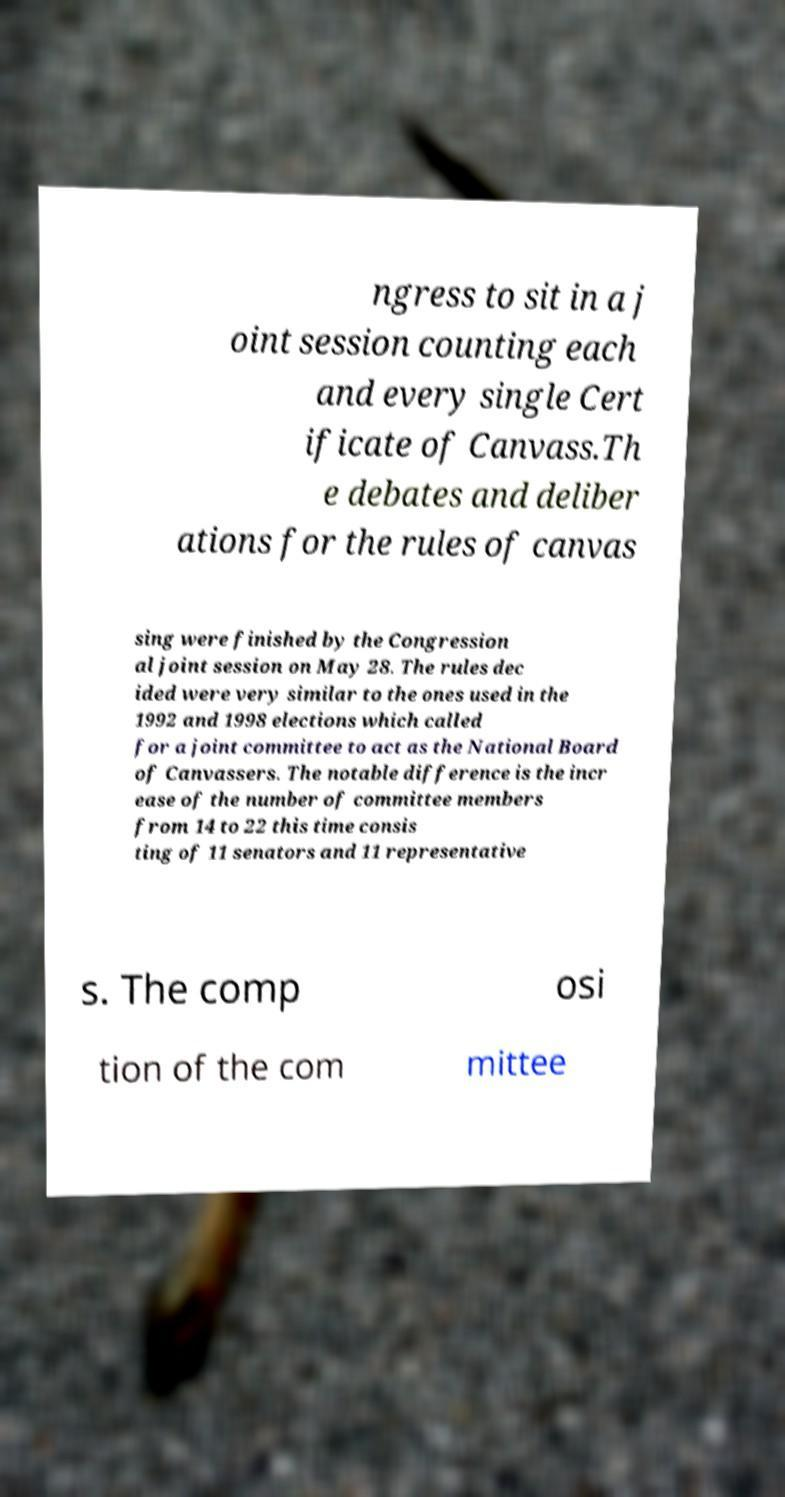Can you accurately transcribe the text from the provided image for me? ngress to sit in a j oint session counting each and every single Cert ificate of Canvass.Th e debates and deliber ations for the rules of canvas sing were finished by the Congression al joint session on May 28. The rules dec ided were very similar to the ones used in the 1992 and 1998 elections which called for a joint committee to act as the National Board of Canvassers. The notable difference is the incr ease of the number of committee members from 14 to 22 this time consis ting of 11 senators and 11 representative s. The comp osi tion of the com mittee 